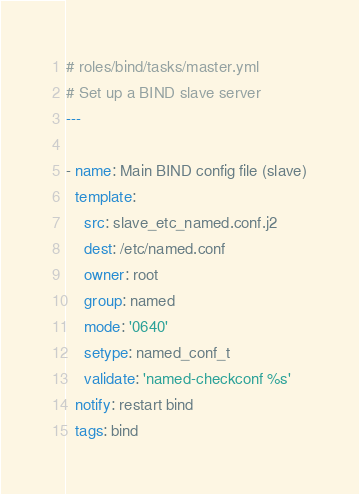<code> <loc_0><loc_0><loc_500><loc_500><_YAML_># roles/bind/tasks/master.yml
# Set up a BIND slave server
---

- name: Main BIND config file (slave)
  template:
    src: slave_etc_named.conf.j2
    dest: /etc/named.conf
    owner: root
    group: named
    mode: '0640'
    setype: named_conf_t
    validate: 'named-checkconf %s'
  notify: restart bind
  tags: bind

</code> 